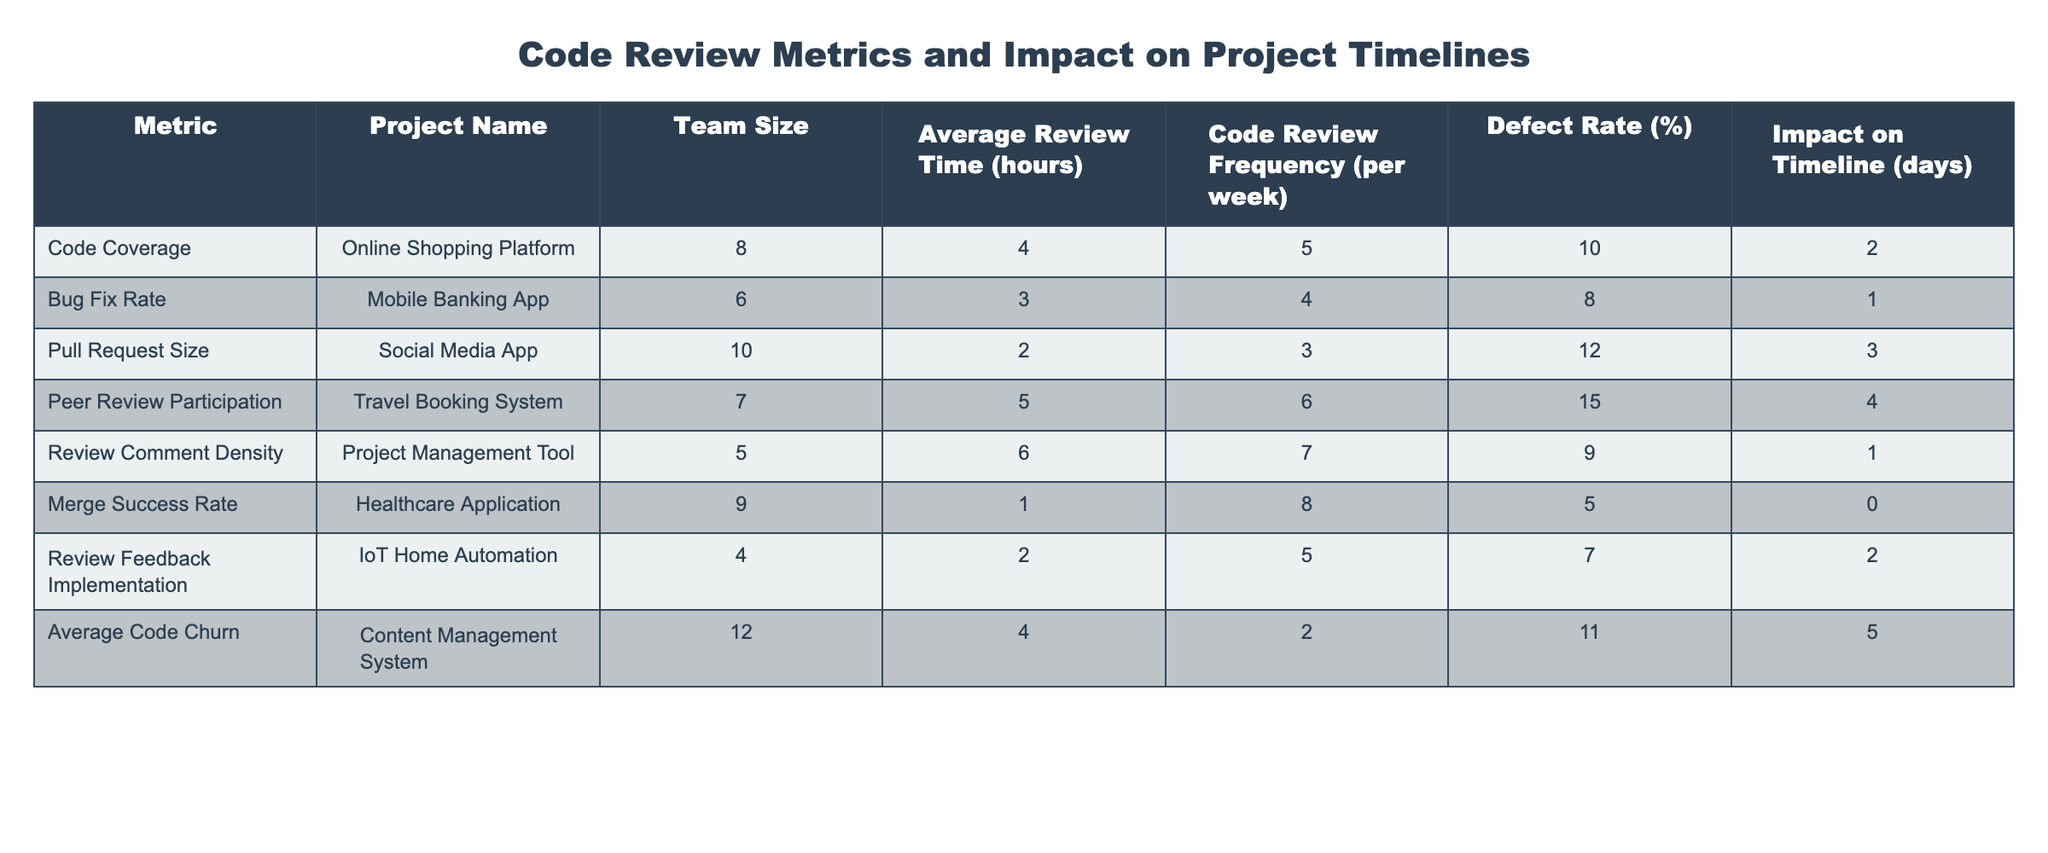What is the average review time for the Healthcare Application? The average review time for the Healthcare Application is listed in the table under the "Average Review Time" column, which shows 1 hour for that project.
Answer: 1 hour What project has the highest defect rate? By comparing the values in the "Defect Rate" column, the Social Media App has the highest defect rate at 12%.
Answer: Social Media App How many projects have an average review time greater than 4 hours? The projects with average review times over 4 hours are the Online Shopping Platform (4 hours), the Travel Booking System (5 hours), and the Project Management Tool (6 hours), totaling 3 projects.
Answer: 3 projects Which project has the lowest impact on the timeline? The impact on the timeline is lowest for the Healthcare Application, which has an impact of 0 days.
Answer: 0 days Is the average code churn for the Content Management System higher than that of the Mobile Banking App? Looking at the "Average Code Churn" values, the Content Management System has a churn of 4, while the Mobile Banking App is 4 as well, hence they are equal.
Answer: No What is the total impact on the timeline of all projects? To find the total impact, sum all values in the "Impact on Timeline" column: 2 + 1 + 3 + 4 + 1 + 0 + 2 + 5 = 18 days.
Answer: 18 days Which project has the highest code review frequency and what is the value? By scanning the "Code Review Frequency" column, the Travel Booking System shows the highest frequency at 8 reviews per week.
Answer: Travel Booking System, 8 What is the average defect rate for projects with a team size of 8 or more? The defects for projects with a team size of 8 or more (Online Shopping Platform, Healthcare Application, and Content Management System) are 10%, 5%, and 11% respectively. Their average is calculated as (10 + 5 + 11) / 3 = 8.67%.
Answer: 8.67% 